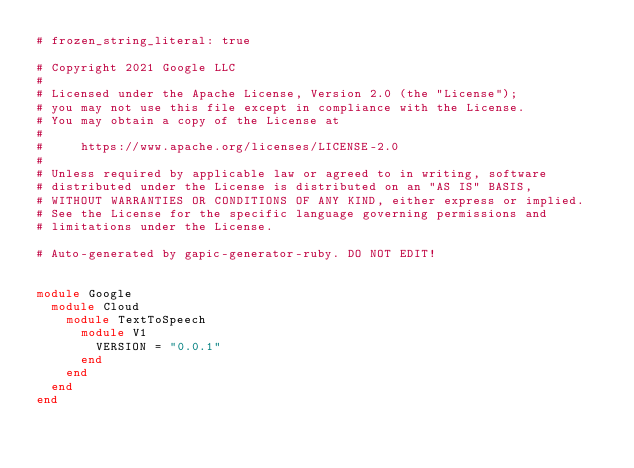<code> <loc_0><loc_0><loc_500><loc_500><_Ruby_># frozen_string_literal: true

# Copyright 2021 Google LLC
#
# Licensed under the Apache License, Version 2.0 (the "License");
# you may not use this file except in compliance with the License.
# You may obtain a copy of the License at
#
#     https://www.apache.org/licenses/LICENSE-2.0
#
# Unless required by applicable law or agreed to in writing, software
# distributed under the License is distributed on an "AS IS" BASIS,
# WITHOUT WARRANTIES OR CONDITIONS OF ANY KIND, either express or implied.
# See the License for the specific language governing permissions and
# limitations under the License.

# Auto-generated by gapic-generator-ruby. DO NOT EDIT!


module Google
  module Cloud
    module TextToSpeech
      module V1
        VERSION = "0.0.1"
      end
    end
  end
end
</code> 